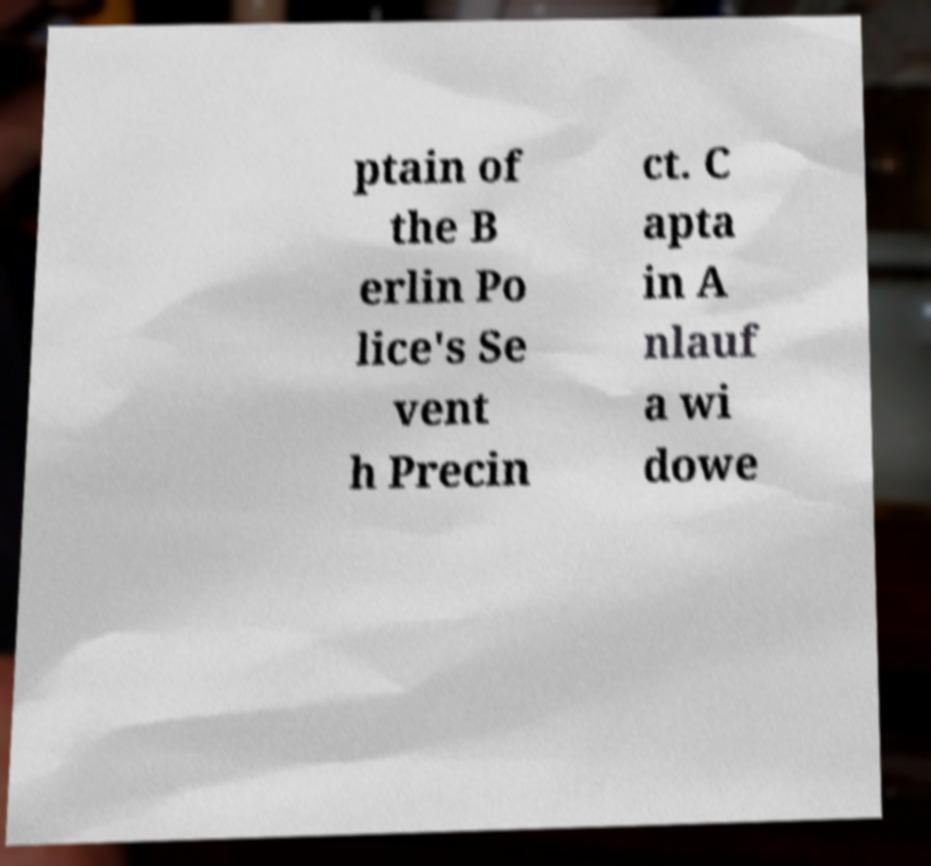There's text embedded in this image that I need extracted. Can you transcribe it verbatim? ptain of the B erlin Po lice's Se vent h Precin ct. C apta in A nlauf a wi dowe 